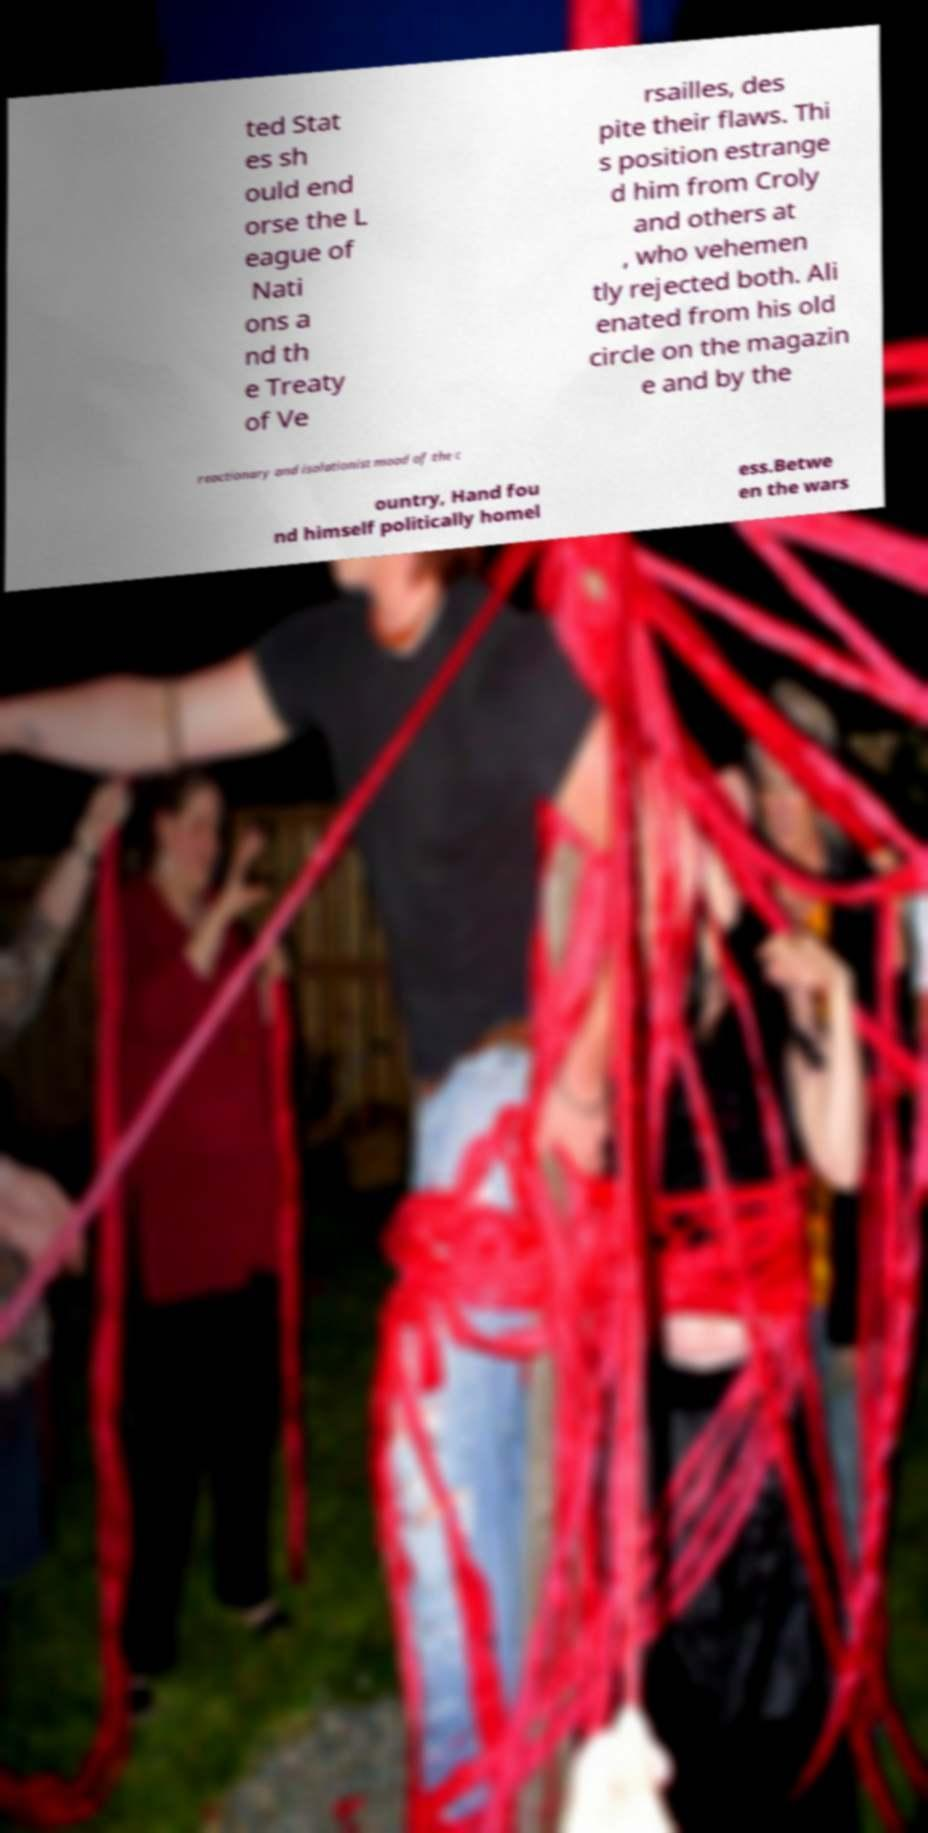For documentation purposes, I need the text within this image transcribed. Could you provide that? ted Stat es sh ould end orse the L eague of Nati ons a nd th e Treaty of Ve rsailles, des pite their flaws. Thi s position estrange d him from Croly and others at , who vehemen tly rejected both. Ali enated from his old circle on the magazin e and by the reactionary and isolationist mood of the c ountry, Hand fou nd himself politically homel ess.Betwe en the wars 